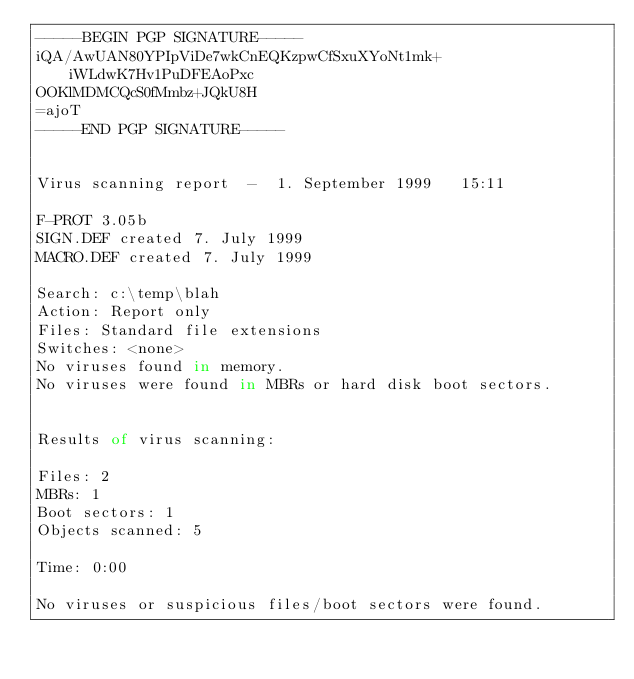<code> <loc_0><loc_0><loc_500><loc_500><_SML_>-----BEGIN PGP SIGNATURE-----
iQA/AwUAN80YPIpViDe7wkCnEQKzpwCfSxuXYoNt1mk+iWLdwK7Hv1PuDFEAoPxc
OOKlMDMCQcS0fMmbz+JQkU8H
=ajoT
-----END PGP SIGNATURE-----


Virus scanning report  -  1. September 1999   15:11

F-PROT 3.05b
SIGN.DEF created 7. July 1999
MACRO.DEF created 7. July 1999

Search: c:\temp\blah
Action: Report only
Files: Standard file extensions
Switches: <none>
No viruses found in memory.
No viruses were found in MBRs or hard disk boot sectors.


Results of virus scanning:

Files: 2
MBRs: 1
Boot sectors: 1
Objects scanned: 5

Time: 0:00

No viruses or suspicious files/boot sectors were found.
</code> 